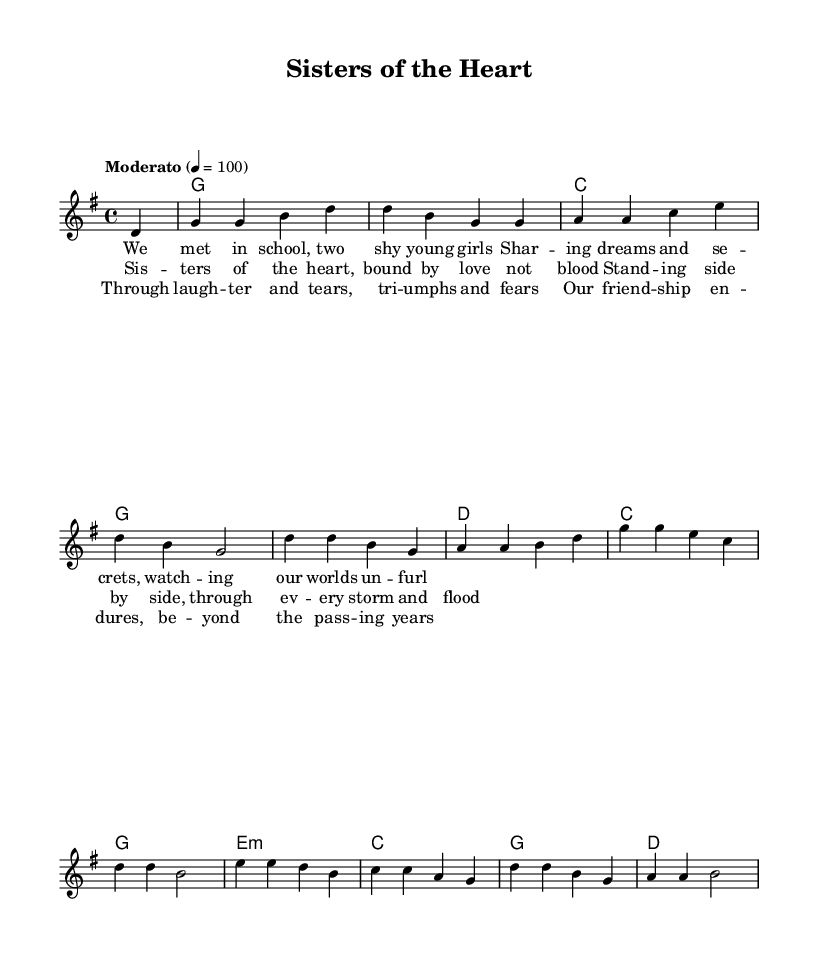What is the key signature of this music? The key signature is G major, which has one sharp (F#), identifiable at the beginning of the staff.
Answer: G major What is the time signature of the piece? The time signature is 4/4, clearly indicated at the beginning of the staff, which means there are four beats per measure.
Answer: 4/4 What tempo marking is provided? The tempo marking is "Moderato," which suggests a moderately paced performance, often around 100 beats per minute as noted in the score.
Answer: Moderato How many sections does the song have? The song consists of three distinct sections: the verse, the chorus, and the bridge, which can be identified by their lyrical content and structural placement.
Answer: Three What is the first lyric line of the verse? The first lyric line of the verse is "We met in school, two shy young girls," found underneath the melody in the lyrics section.
Answer: We met in school, two shy young girls Which chord is played on the first beat of the song? The chord played on the first beat is G major, indicated by the "g1" symbol at the beginning of the harmonies section.
Answer: G major What is the lyrical theme of the chorus? The lyrical theme of the chorus focuses on the bond of sisterhood and support, which is conveyed through the lines that describe standing together through challenges.
Answer: Sisterhood and support 